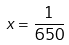<formula> <loc_0><loc_0><loc_500><loc_500>x = \frac { 1 } { 6 5 0 }</formula> 